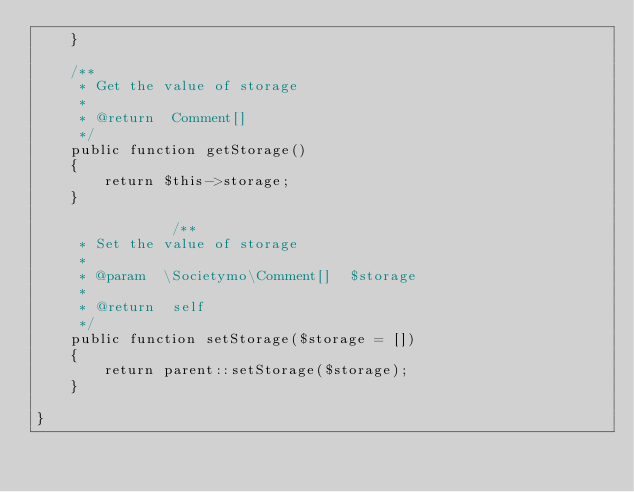Convert code to text. <code><loc_0><loc_0><loc_500><loc_500><_PHP_>    }

    /**
     * Get the value of storage
     *
     * @return  Comment[]
     */ 
    public function getStorage()
    {
        return $this->storage;
    }

                /**
     * Set the value of storage
     *
     * @param  \Societymo\Comment[]  $storage
     *
     * @return  self
     */ 
    public function setStorage($storage = [])
    {
        return parent::setStorage($storage);
    }

}</code> 